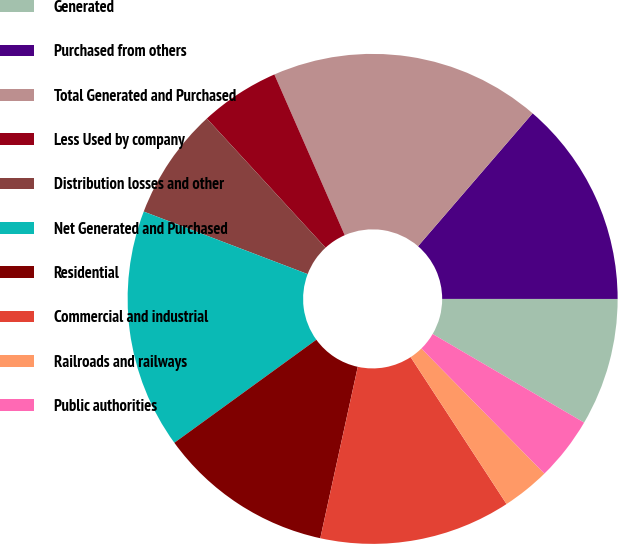<chart> <loc_0><loc_0><loc_500><loc_500><pie_chart><fcel>Generated<fcel>Purchased from others<fcel>Total Generated and Purchased<fcel>Less Used by company<fcel>Distribution losses and other<fcel>Net Generated and Purchased<fcel>Residential<fcel>Commercial and industrial<fcel>Railroads and railways<fcel>Public authorities<nl><fcel>8.42%<fcel>13.68%<fcel>17.89%<fcel>5.26%<fcel>7.37%<fcel>15.79%<fcel>11.58%<fcel>12.63%<fcel>3.16%<fcel>4.21%<nl></chart> 